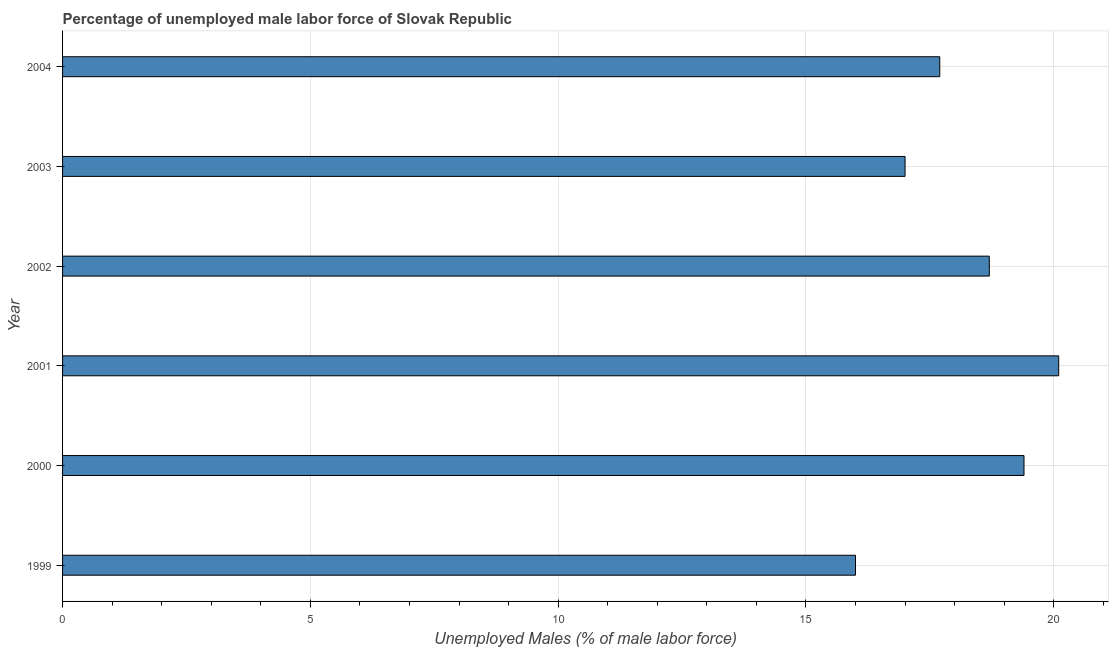Does the graph contain any zero values?
Your response must be concise. No. Does the graph contain grids?
Offer a very short reply. Yes. What is the title of the graph?
Provide a short and direct response. Percentage of unemployed male labor force of Slovak Republic. What is the label or title of the X-axis?
Provide a succinct answer. Unemployed Males (% of male labor force). What is the label or title of the Y-axis?
Offer a terse response. Year. What is the total unemployed male labour force in 2003?
Make the answer very short. 17. Across all years, what is the maximum total unemployed male labour force?
Ensure brevity in your answer.  20.1. Across all years, what is the minimum total unemployed male labour force?
Make the answer very short. 16. What is the sum of the total unemployed male labour force?
Offer a very short reply. 108.9. What is the difference between the total unemployed male labour force in 2002 and 2004?
Keep it short and to the point. 1. What is the average total unemployed male labour force per year?
Offer a terse response. 18.15. What is the median total unemployed male labour force?
Keep it short and to the point. 18.2. Do a majority of the years between 2002 and 2001 (inclusive) have total unemployed male labour force greater than 17 %?
Offer a terse response. No. What is the ratio of the total unemployed male labour force in 1999 to that in 2003?
Offer a very short reply. 0.94. Is the total unemployed male labour force in 1999 less than that in 2003?
Your answer should be compact. Yes. Is the difference between the total unemployed male labour force in 1999 and 2001 greater than the difference between any two years?
Offer a very short reply. Yes. What is the difference between the highest and the second highest total unemployed male labour force?
Ensure brevity in your answer.  0.7. Is the sum of the total unemployed male labour force in 1999 and 2001 greater than the maximum total unemployed male labour force across all years?
Keep it short and to the point. Yes. In how many years, is the total unemployed male labour force greater than the average total unemployed male labour force taken over all years?
Your answer should be compact. 3. How many bars are there?
Give a very brief answer. 6. How many years are there in the graph?
Offer a terse response. 6. What is the Unemployed Males (% of male labor force) in 1999?
Your answer should be compact. 16. What is the Unemployed Males (% of male labor force) of 2000?
Give a very brief answer. 19.4. What is the Unemployed Males (% of male labor force) of 2001?
Offer a terse response. 20.1. What is the Unemployed Males (% of male labor force) of 2002?
Your answer should be very brief. 18.7. What is the Unemployed Males (% of male labor force) in 2003?
Your response must be concise. 17. What is the Unemployed Males (% of male labor force) in 2004?
Offer a terse response. 17.7. What is the difference between the Unemployed Males (% of male labor force) in 1999 and 2000?
Provide a succinct answer. -3.4. What is the difference between the Unemployed Males (% of male labor force) in 1999 and 2001?
Keep it short and to the point. -4.1. What is the difference between the Unemployed Males (% of male labor force) in 1999 and 2004?
Give a very brief answer. -1.7. What is the difference between the Unemployed Males (% of male labor force) in 2000 and 2001?
Make the answer very short. -0.7. What is the difference between the Unemployed Males (% of male labor force) in 2000 and 2002?
Provide a short and direct response. 0.7. What is the difference between the Unemployed Males (% of male labor force) in 2002 and 2003?
Provide a succinct answer. 1.7. What is the difference between the Unemployed Males (% of male labor force) in 2003 and 2004?
Your answer should be compact. -0.7. What is the ratio of the Unemployed Males (% of male labor force) in 1999 to that in 2000?
Keep it short and to the point. 0.82. What is the ratio of the Unemployed Males (% of male labor force) in 1999 to that in 2001?
Offer a terse response. 0.8. What is the ratio of the Unemployed Males (% of male labor force) in 1999 to that in 2002?
Ensure brevity in your answer.  0.86. What is the ratio of the Unemployed Males (% of male labor force) in 1999 to that in 2003?
Ensure brevity in your answer.  0.94. What is the ratio of the Unemployed Males (% of male labor force) in 1999 to that in 2004?
Give a very brief answer. 0.9. What is the ratio of the Unemployed Males (% of male labor force) in 2000 to that in 2002?
Your answer should be compact. 1.04. What is the ratio of the Unemployed Males (% of male labor force) in 2000 to that in 2003?
Provide a short and direct response. 1.14. What is the ratio of the Unemployed Males (% of male labor force) in 2000 to that in 2004?
Offer a very short reply. 1.1. What is the ratio of the Unemployed Males (% of male labor force) in 2001 to that in 2002?
Your answer should be compact. 1.07. What is the ratio of the Unemployed Males (% of male labor force) in 2001 to that in 2003?
Your answer should be very brief. 1.18. What is the ratio of the Unemployed Males (% of male labor force) in 2001 to that in 2004?
Your response must be concise. 1.14. What is the ratio of the Unemployed Males (% of male labor force) in 2002 to that in 2004?
Your answer should be compact. 1.06. 